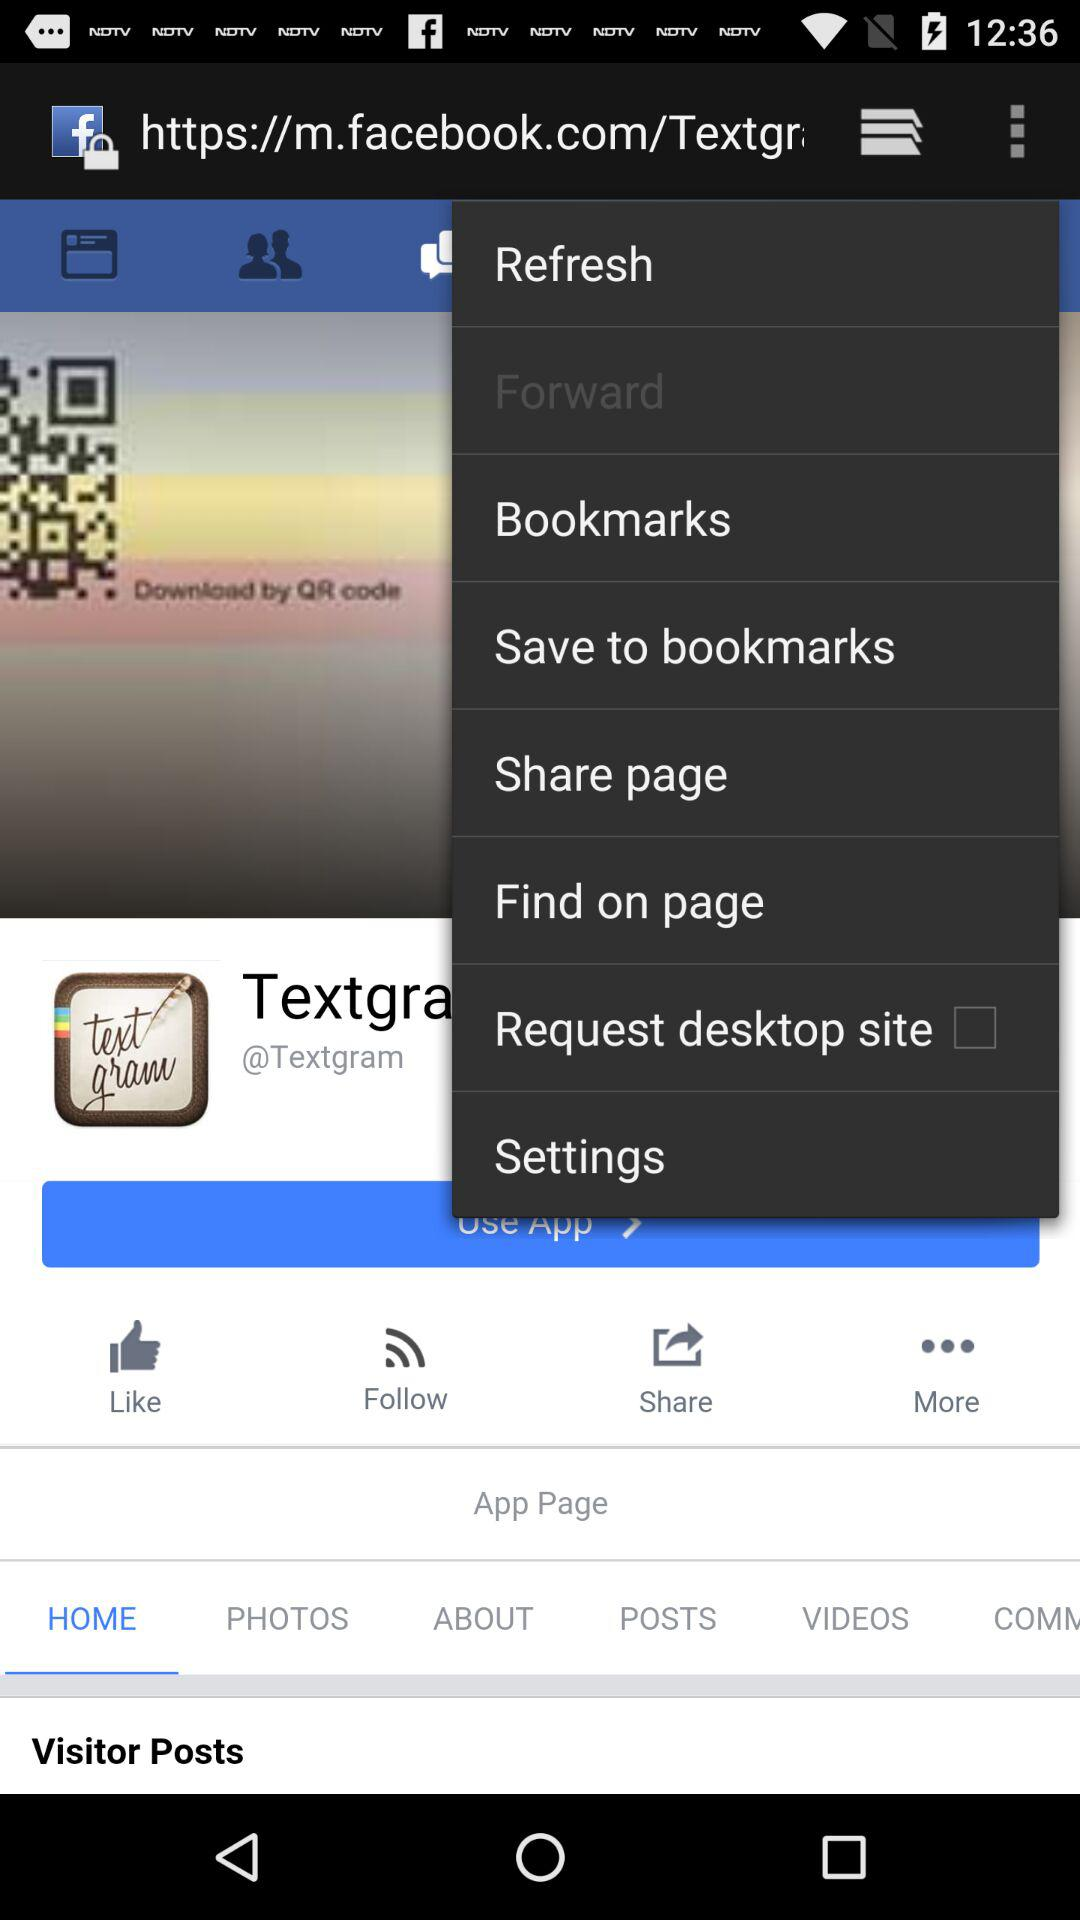Which tab is selected? The selected tab is "HOME". 